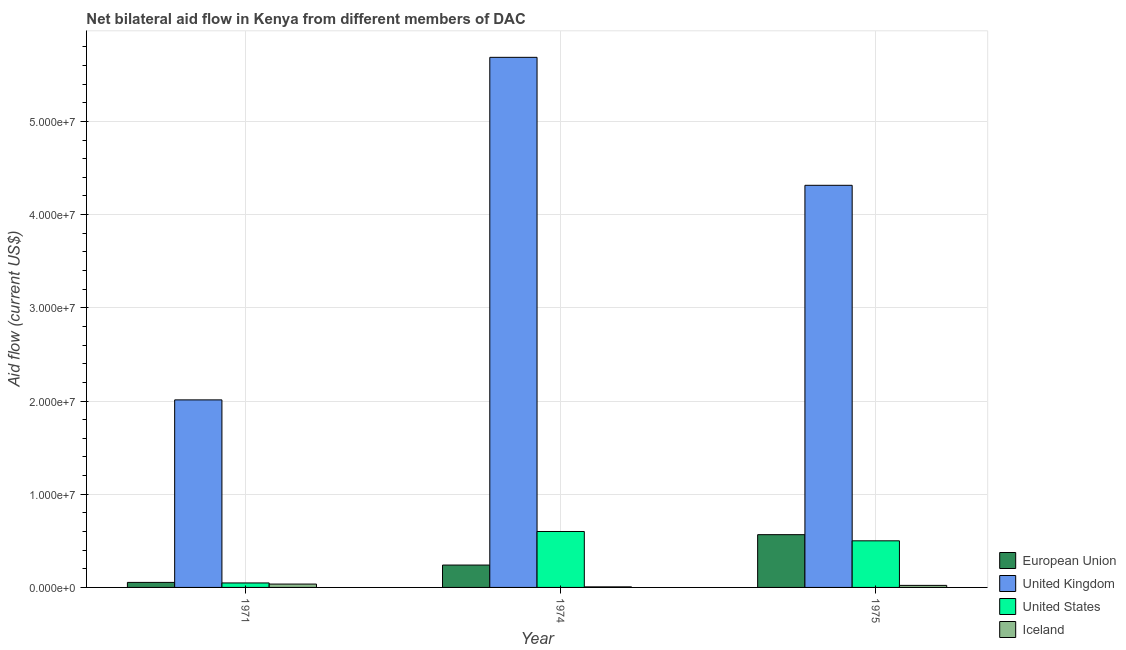How many groups of bars are there?
Keep it short and to the point. 3. Are the number of bars per tick equal to the number of legend labels?
Your answer should be compact. Yes. Are the number of bars on each tick of the X-axis equal?
Offer a terse response. Yes. How many bars are there on the 3rd tick from the right?
Provide a succinct answer. 4. What is the label of the 2nd group of bars from the left?
Ensure brevity in your answer.  1974. What is the amount of aid given by uk in 1974?
Ensure brevity in your answer.  5.69e+07. Across all years, what is the maximum amount of aid given by eu?
Make the answer very short. 5.66e+06. Across all years, what is the minimum amount of aid given by us?
Your answer should be very brief. 4.80e+05. In which year was the amount of aid given by iceland maximum?
Offer a terse response. 1971. In which year was the amount of aid given by us minimum?
Keep it short and to the point. 1971. What is the total amount of aid given by eu in the graph?
Keep it short and to the point. 8.60e+06. What is the difference between the amount of aid given by iceland in 1971 and that in 1974?
Provide a succinct answer. 3.00e+05. What is the difference between the amount of aid given by us in 1971 and the amount of aid given by uk in 1975?
Your answer should be compact. -4.52e+06. What is the average amount of aid given by uk per year?
Provide a short and direct response. 4.00e+07. In the year 1971, what is the difference between the amount of aid given by iceland and amount of aid given by us?
Your answer should be very brief. 0. In how many years, is the amount of aid given by eu greater than 28000000 US$?
Provide a succinct answer. 0. What is the ratio of the amount of aid given by us in 1974 to that in 1975?
Make the answer very short. 1.2. What is the difference between the highest and the lowest amount of aid given by eu?
Offer a very short reply. 5.12e+06. Is it the case that in every year, the sum of the amount of aid given by us and amount of aid given by iceland is greater than the sum of amount of aid given by eu and amount of aid given by uk?
Your response must be concise. Yes. What does the 1st bar from the right in 1971 represents?
Your answer should be very brief. Iceland. Is it the case that in every year, the sum of the amount of aid given by eu and amount of aid given by uk is greater than the amount of aid given by us?
Provide a short and direct response. Yes. How many bars are there?
Make the answer very short. 12. Are all the bars in the graph horizontal?
Make the answer very short. No. How many years are there in the graph?
Offer a terse response. 3. What is the difference between two consecutive major ticks on the Y-axis?
Your response must be concise. 1.00e+07. Are the values on the major ticks of Y-axis written in scientific E-notation?
Offer a very short reply. Yes. Where does the legend appear in the graph?
Your response must be concise. Bottom right. How are the legend labels stacked?
Give a very brief answer. Vertical. What is the title of the graph?
Ensure brevity in your answer.  Net bilateral aid flow in Kenya from different members of DAC. What is the label or title of the X-axis?
Provide a short and direct response. Year. What is the Aid flow (current US$) in European Union in 1971?
Provide a short and direct response. 5.40e+05. What is the Aid flow (current US$) in United Kingdom in 1971?
Offer a terse response. 2.01e+07. What is the Aid flow (current US$) of United States in 1971?
Provide a succinct answer. 4.80e+05. What is the Aid flow (current US$) in European Union in 1974?
Provide a short and direct response. 2.40e+06. What is the Aid flow (current US$) of United Kingdom in 1974?
Keep it short and to the point. 5.69e+07. What is the Aid flow (current US$) in Iceland in 1974?
Your answer should be compact. 6.00e+04. What is the Aid flow (current US$) of European Union in 1975?
Make the answer very short. 5.66e+06. What is the Aid flow (current US$) in United Kingdom in 1975?
Offer a terse response. 4.31e+07. What is the Aid flow (current US$) in United States in 1975?
Provide a short and direct response. 5.00e+06. Across all years, what is the maximum Aid flow (current US$) in European Union?
Provide a succinct answer. 5.66e+06. Across all years, what is the maximum Aid flow (current US$) in United Kingdom?
Keep it short and to the point. 5.69e+07. Across all years, what is the minimum Aid flow (current US$) in European Union?
Make the answer very short. 5.40e+05. Across all years, what is the minimum Aid flow (current US$) of United Kingdom?
Make the answer very short. 2.01e+07. Across all years, what is the minimum Aid flow (current US$) of Iceland?
Keep it short and to the point. 6.00e+04. What is the total Aid flow (current US$) in European Union in the graph?
Offer a terse response. 8.60e+06. What is the total Aid flow (current US$) in United Kingdom in the graph?
Your answer should be very brief. 1.20e+08. What is the total Aid flow (current US$) of United States in the graph?
Keep it short and to the point. 1.15e+07. What is the total Aid flow (current US$) in Iceland in the graph?
Give a very brief answer. 6.40e+05. What is the difference between the Aid flow (current US$) in European Union in 1971 and that in 1974?
Your response must be concise. -1.86e+06. What is the difference between the Aid flow (current US$) in United Kingdom in 1971 and that in 1974?
Offer a terse response. -3.68e+07. What is the difference between the Aid flow (current US$) in United States in 1971 and that in 1974?
Make the answer very short. -5.52e+06. What is the difference between the Aid flow (current US$) of Iceland in 1971 and that in 1974?
Provide a short and direct response. 3.00e+05. What is the difference between the Aid flow (current US$) of European Union in 1971 and that in 1975?
Your answer should be very brief. -5.12e+06. What is the difference between the Aid flow (current US$) in United Kingdom in 1971 and that in 1975?
Give a very brief answer. -2.30e+07. What is the difference between the Aid flow (current US$) of United States in 1971 and that in 1975?
Give a very brief answer. -4.52e+06. What is the difference between the Aid flow (current US$) in Iceland in 1971 and that in 1975?
Provide a succinct answer. 1.40e+05. What is the difference between the Aid flow (current US$) of European Union in 1974 and that in 1975?
Keep it short and to the point. -3.26e+06. What is the difference between the Aid flow (current US$) in United Kingdom in 1974 and that in 1975?
Your answer should be very brief. 1.37e+07. What is the difference between the Aid flow (current US$) of United States in 1974 and that in 1975?
Your answer should be compact. 1.00e+06. What is the difference between the Aid flow (current US$) of Iceland in 1974 and that in 1975?
Provide a short and direct response. -1.60e+05. What is the difference between the Aid flow (current US$) of European Union in 1971 and the Aid flow (current US$) of United Kingdom in 1974?
Offer a terse response. -5.63e+07. What is the difference between the Aid flow (current US$) in European Union in 1971 and the Aid flow (current US$) in United States in 1974?
Offer a terse response. -5.46e+06. What is the difference between the Aid flow (current US$) in United Kingdom in 1971 and the Aid flow (current US$) in United States in 1974?
Ensure brevity in your answer.  1.41e+07. What is the difference between the Aid flow (current US$) in United Kingdom in 1971 and the Aid flow (current US$) in Iceland in 1974?
Your answer should be very brief. 2.01e+07. What is the difference between the Aid flow (current US$) of European Union in 1971 and the Aid flow (current US$) of United Kingdom in 1975?
Your answer should be very brief. -4.26e+07. What is the difference between the Aid flow (current US$) of European Union in 1971 and the Aid flow (current US$) of United States in 1975?
Offer a terse response. -4.46e+06. What is the difference between the Aid flow (current US$) in European Union in 1971 and the Aid flow (current US$) in Iceland in 1975?
Provide a succinct answer. 3.20e+05. What is the difference between the Aid flow (current US$) of United Kingdom in 1971 and the Aid flow (current US$) of United States in 1975?
Your answer should be very brief. 1.51e+07. What is the difference between the Aid flow (current US$) of United Kingdom in 1971 and the Aid flow (current US$) of Iceland in 1975?
Your response must be concise. 1.99e+07. What is the difference between the Aid flow (current US$) in United States in 1971 and the Aid flow (current US$) in Iceland in 1975?
Ensure brevity in your answer.  2.60e+05. What is the difference between the Aid flow (current US$) of European Union in 1974 and the Aid flow (current US$) of United Kingdom in 1975?
Offer a terse response. -4.07e+07. What is the difference between the Aid flow (current US$) in European Union in 1974 and the Aid flow (current US$) in United States in 1975?
Provide a succinct answer. -2.60e+06. What is the difference between the Aid flow (current US$) in European Union in 1974 and the Aid flow (current US$) in Iceland in 1975?
Ensure brevity in your answer.  2.18e+06. What is the difference between the Aid flow (current US$) of United Kingdom in 1974 and the Aid flow (current US$) of United States in 1975?
Your answer should be compact. 5.19e+07. What is the difference between the Aid flow (current US$) of United Kingdom in 1974 and the Aid flow (current US$) of Iceland in 1975?
Ensure brevity in your answer.  5.66e+07. What is the difference between the Aid flow (current US$) in United States in 1974 and the Aid flow (current US$) in Iceland in 1975?
Make the answer very short. 5.78e+06. What is the average Aid flow (current US$) of European Union per year?
Your response must be concise. 2.87e+06. What is the average Aid flow (current US$) of United Kingdom per year?
Give a very brief answer. 4.00e+07. What is the average Aid flow (current US$) in United States per year?
Ensure brevity in your answer.  3.83e+06. What is the average Aid flow (current US$) in Iceland per year?
Your response must be concise. 2.13e+05. In the year 1971, what is the difference between the Aid flow (current US$) of European Union and Aid flow (current US$) of United Kingdom?
Provide a succinct answer. -1.96e+07. In the year 1971, what is the difference between the Aid flow (current US$) of European Union and Aid flow (current US$) of Iceland?
Keep it short and to the point. 1.80e+05. In the year 1971, what is the difference between the Aid flow (current US$) of United Kingdom and Aid flow (current US$) of United States?
Provide a succinct answer. 1.96e+07. In the year 1971, what is the difference between the Aid flow (current US$) in United Kingdom and Aid flow (current US$) in Iceland?
Your answer should be compact. 1.98e+07. In the year 1974, what is the difference between the Aid flow (current US$) of European Union and Aid flow (current US$) of United Kingdom?
Your response must be concise. -5.45e+07. In the year 1974, what is the difference between the Aid flow (current US$) in European Union and Aid flow (current US$) in United States?
Offer a terse response. -3.60e+06. In the year 1974, what is the difference between the Aid flow (current US$) in European Union and Aid flow (current US$) in Iceland?
Offer a terse response. 2.34e+06. In the year 1974, what is the difference between the Aid flow (current US$) in United Kingdom and Aid flow (current US$) in United States?
Make the answer very short. 5.09e+07. In the year 1974, what is the difference between the Aid flow (current US$) in United Kingdom and Aid flow (current US$) in Iceland?
Provide a short and direct response. 5.68e+07. In the year 1974, what is the difference between the Aid flow (current US$) of United States and Aid flow (current US$) of Iceland?
Your response must be concise. 5.94e+06. In the year 1975, what is the difference between the Aid flow (current US$) of European Union and Aid flow (current US$) of United Kingdom?
Offer a terse response. -3.75e+07. In the year 1975, what is the difference between the Aid flow (current US$) of European Union and Aid flow (current US$) of Iceland?
Your answer should be very brief. 5.44e+06. In the year 1975, what is the difference between the Aid flow (current US$) of United Kingdom and Aid flow (current US$) of United States?
Ensure brevity in your answer.  3.81e+07. In the year 1975, what is the difference between the Aid flow (current US$) of United Kingdom and Aid flow (current US$) of Iceland?
Ensure brevity in your answer.  4.29e+07. In the year 1975, what is the difference between the Aid flow (current US$) of United States and Aid flow (current US$) of Iceland?
Give a very brief answer. 4.78e+06. What is the ratio of the Aid flow (current US$) in European Union in 1971 to that in 1974?
Provide a succinct answer. 0.23. What is the ratio of the Aid flow (current US$) of United Kingdom in 1971 to that in 1974?
Offer a terse response. 0.35. What is the ratio of the Aid flow (current US$) of European Union in 1971 to that in 1975?
Ensure brevity in your answer.  0.1. What is the ratio of the Aid flow (current US$) of United Kingdom in 1971 to that in 1975?
Your answer should be compact. 0.47. What is the ratio of the Aid flow (current US$) of United States in 1971 to that in 1975?
Keep it short and to the point. 0.1. What is the ratio of the Aid flow (current US$) in Iceland in 1971 to that in 1975?
Your answer should be very brief. 1.64. What is the ratio of the Aid flow (current US$) of European Union in 1974 to that in 1975?
Offer a terse response. 0.42. What is the ratio of the Aid flow (current US$) of United Kingdom in 1974 to that in 1975?
Your answer should be compact. 1.32. What is the ratio of the Aid flow (current US$) in Iceland in 1974 to that in 1975?
Your answer should be very brief. 0.27. What is the difference between the highest and the second highest Aid flow (current US$) in European Union?
Offer a very short reply. 3.26e+06. What is the difference between the highest and the second highest Aid flow (current US$) of United Kingdom?
Your response must be concise. 1.37e+07. What is the difference between the highest and the lowest Aid flow (current US$) in European Union?
Keep it short and to the point. 5.12e+06. What is the difference between the highest and the lowest Aid flow (current US$) of United Kingdom?
Offer a very short reply. 3.68e+07. What is the difference between the highest and the lowest Aid flow (current US$) in United States?
Give a very brief answer. 5.52e+06. What is the difference between the highest and the lowest Aid flow (current US$) in Iceland?
Your answer should be compact. 3.00e+05. 